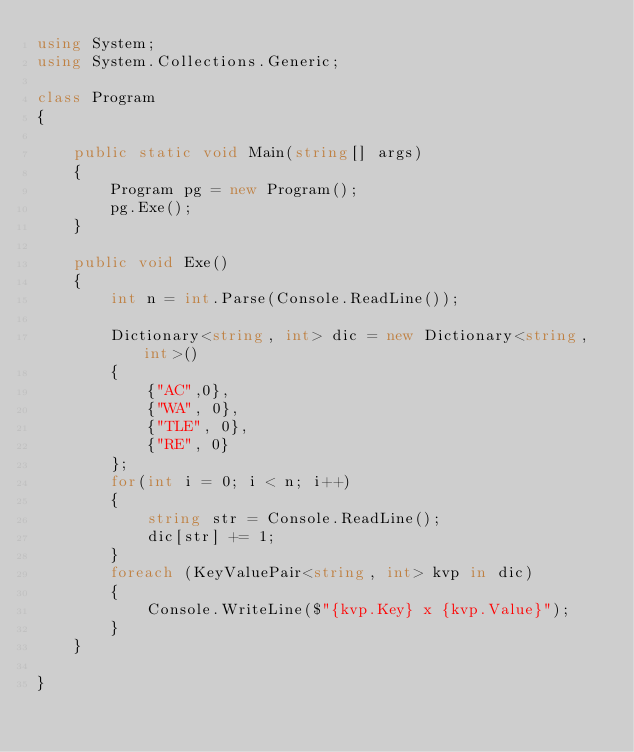<code> <loc_0><loc_0><loc_500><loc_500><_C#_>using System;
using System.Collections.Generic;

class Program
{

    public static void Main(string[] args)
    {
        Program pg = new Program();
        pg.Exe();
    }

    public void Exe()
    {
        int n = int.Parse(Console.ReadLine());

        Dictionary<string, int> dic = new Dictionary<string,int>() 
        {
            {"AC",0},
            {"WA", 0},
            {"TLE", 0},
            {"RE", 0}
        };
        for(int i = 0; i < n; i++)
        {
            string str = Console.ReadLine();
            dic[str] += 1;
        }
        foreach (KeyValuePair<string, int> kvp in dic)
        {
            Console.WriteLine($"{kvp.Key} x {kvp.Value}");
        }
    }

}

</code> 